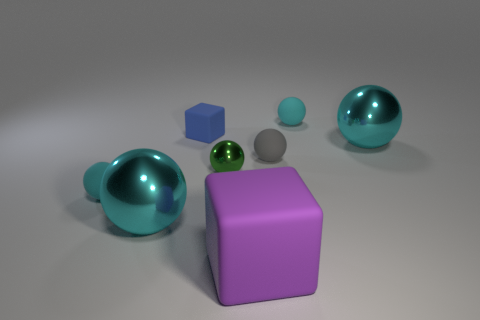Subtract all cyan balls. How many were subtracted if there are1cyan balls left? 3 Subtract all cyan metallic balls. How many balls are left? 4 Add 2 purple rubber objects. How many objects exist? 10 Subtract all cubes. How many objects are left? 6 Add 4 small spheres. How many small spheres are left? 8 Add 4 shiny spheres. How many shiny spheres exist? 7 Subtract all gray spheres. How many spheres are left? 5 Subtract 0 blue balls. How many objects are left? 8 Subtract 1 cubes. How many cubes are left? 1 Subtract all purple blocks. Subtract all blue spheres. How many blocks are left? 1 